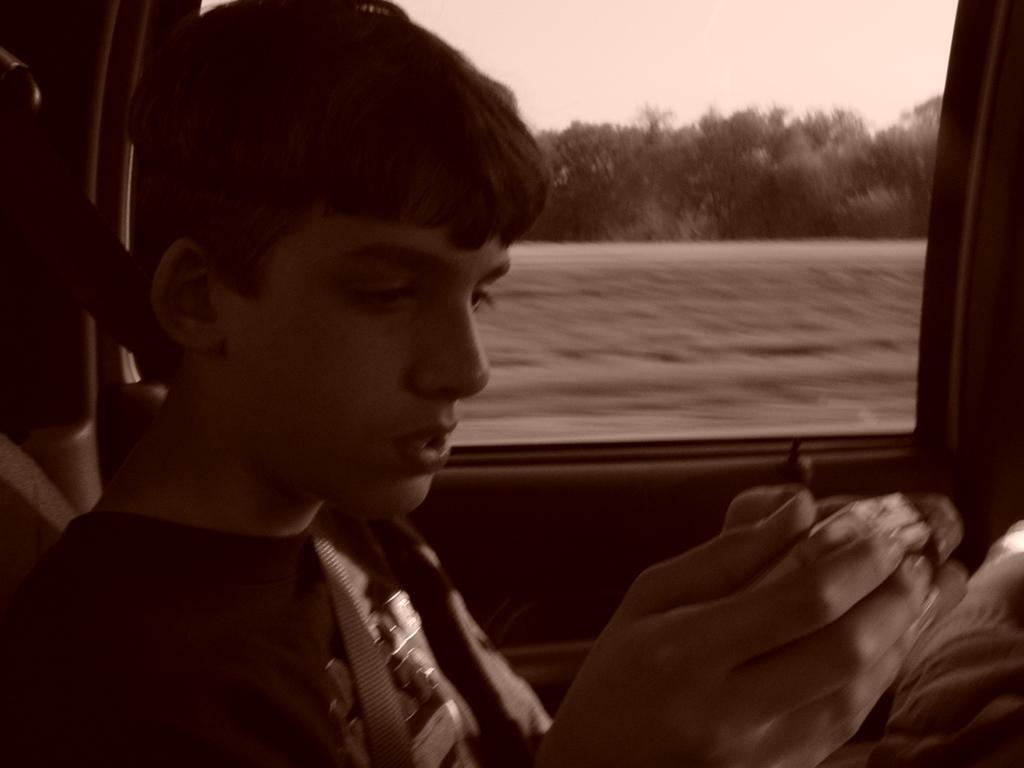Could you give a brief overview of what you see in this image? In this picture there is a boy sitting inside the vehicle and holding the object. Behind the mirror there are trees and there is grass. At the top there is sky. 